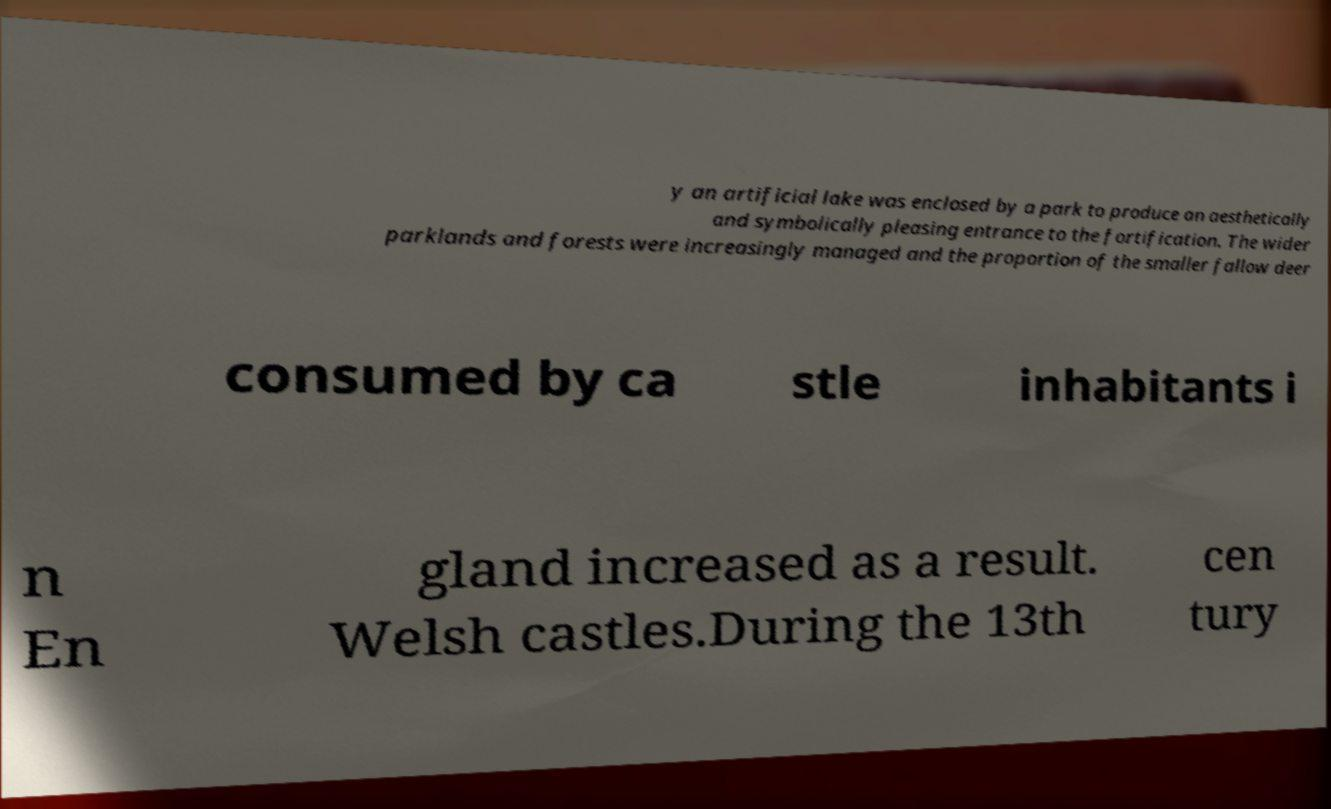Could you extract and type out the text from this image? y an artificial lake was enclosed by a park to produce an aesthetically and symbolically pleasing entrance to the fortification. The wider parklands and forests were increasingly managed and the proportion of the smaller fallow deer consumed by ca stle inhabitants i n En gland increased as a result. Welsh castles.During the 13th cen tury 